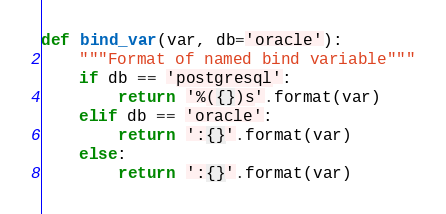Convert code to text. <code><loc_0><loc_0><loc_500><loc_500><_Python_>

def bind_var(var, db='oracle'):
    """Format of named bind variable"""
    if db == 'postgresql':
        return '%({})s'.format(var)
    elif db == 'oracle':
        return ':{}'.format(var)
    else:
        return ':{}'.format(var)</code> 